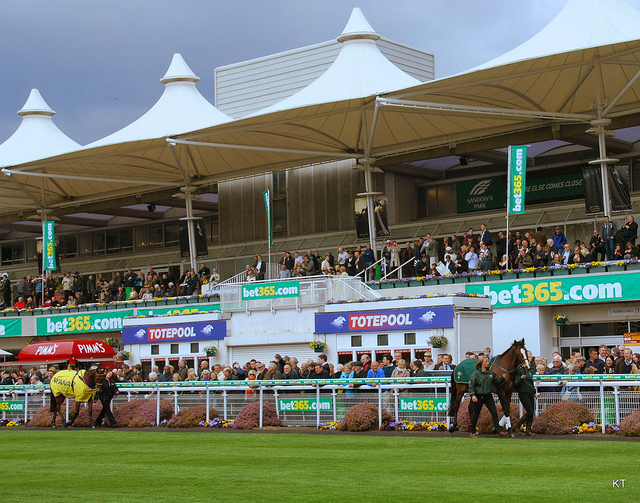Read all the text in this image. TOTEPOOL TOTEPOOL bet365.com BET365COM KT bet365.co bet365.com BWMS saast BET365 COM 